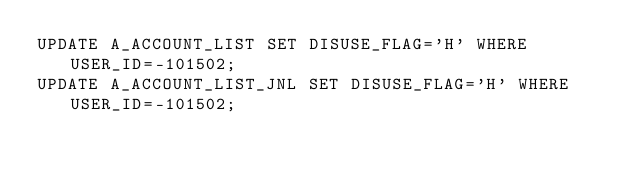<code> <loc_0><loc_0><loc_500><loc_500><_SQL_>UPDATE A_ACCOUNT_LIST SET DISUSE_FLAG='H' WHERE USER_ID=-101502;
UPDATE A_ACCOUNT_LIST_JNL SET DISUSE_FLAG='H' WHERE USER_ID=-101502;
</code> 